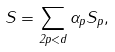Convert formula to latex. <formula><loc_0><loc_0><loc_500><loc_500>S = \sum _ { 2 p < d } \alpha _ { p } S _ { p } ,</formula> 